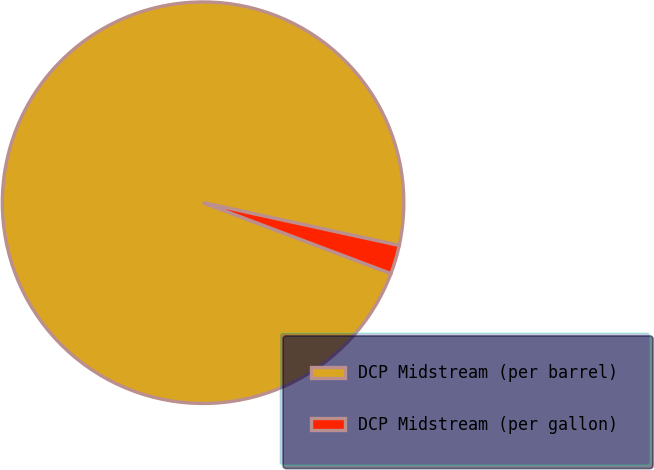<chart> <loc_0><loc_0><loc_500><loc_500><pie_chart><fcel>DCP Midstream (per barrel)<fcel>DCP Midstream (per gallon)<nl><fcel>97.68%<fcel>2.32%<nl></chart> 